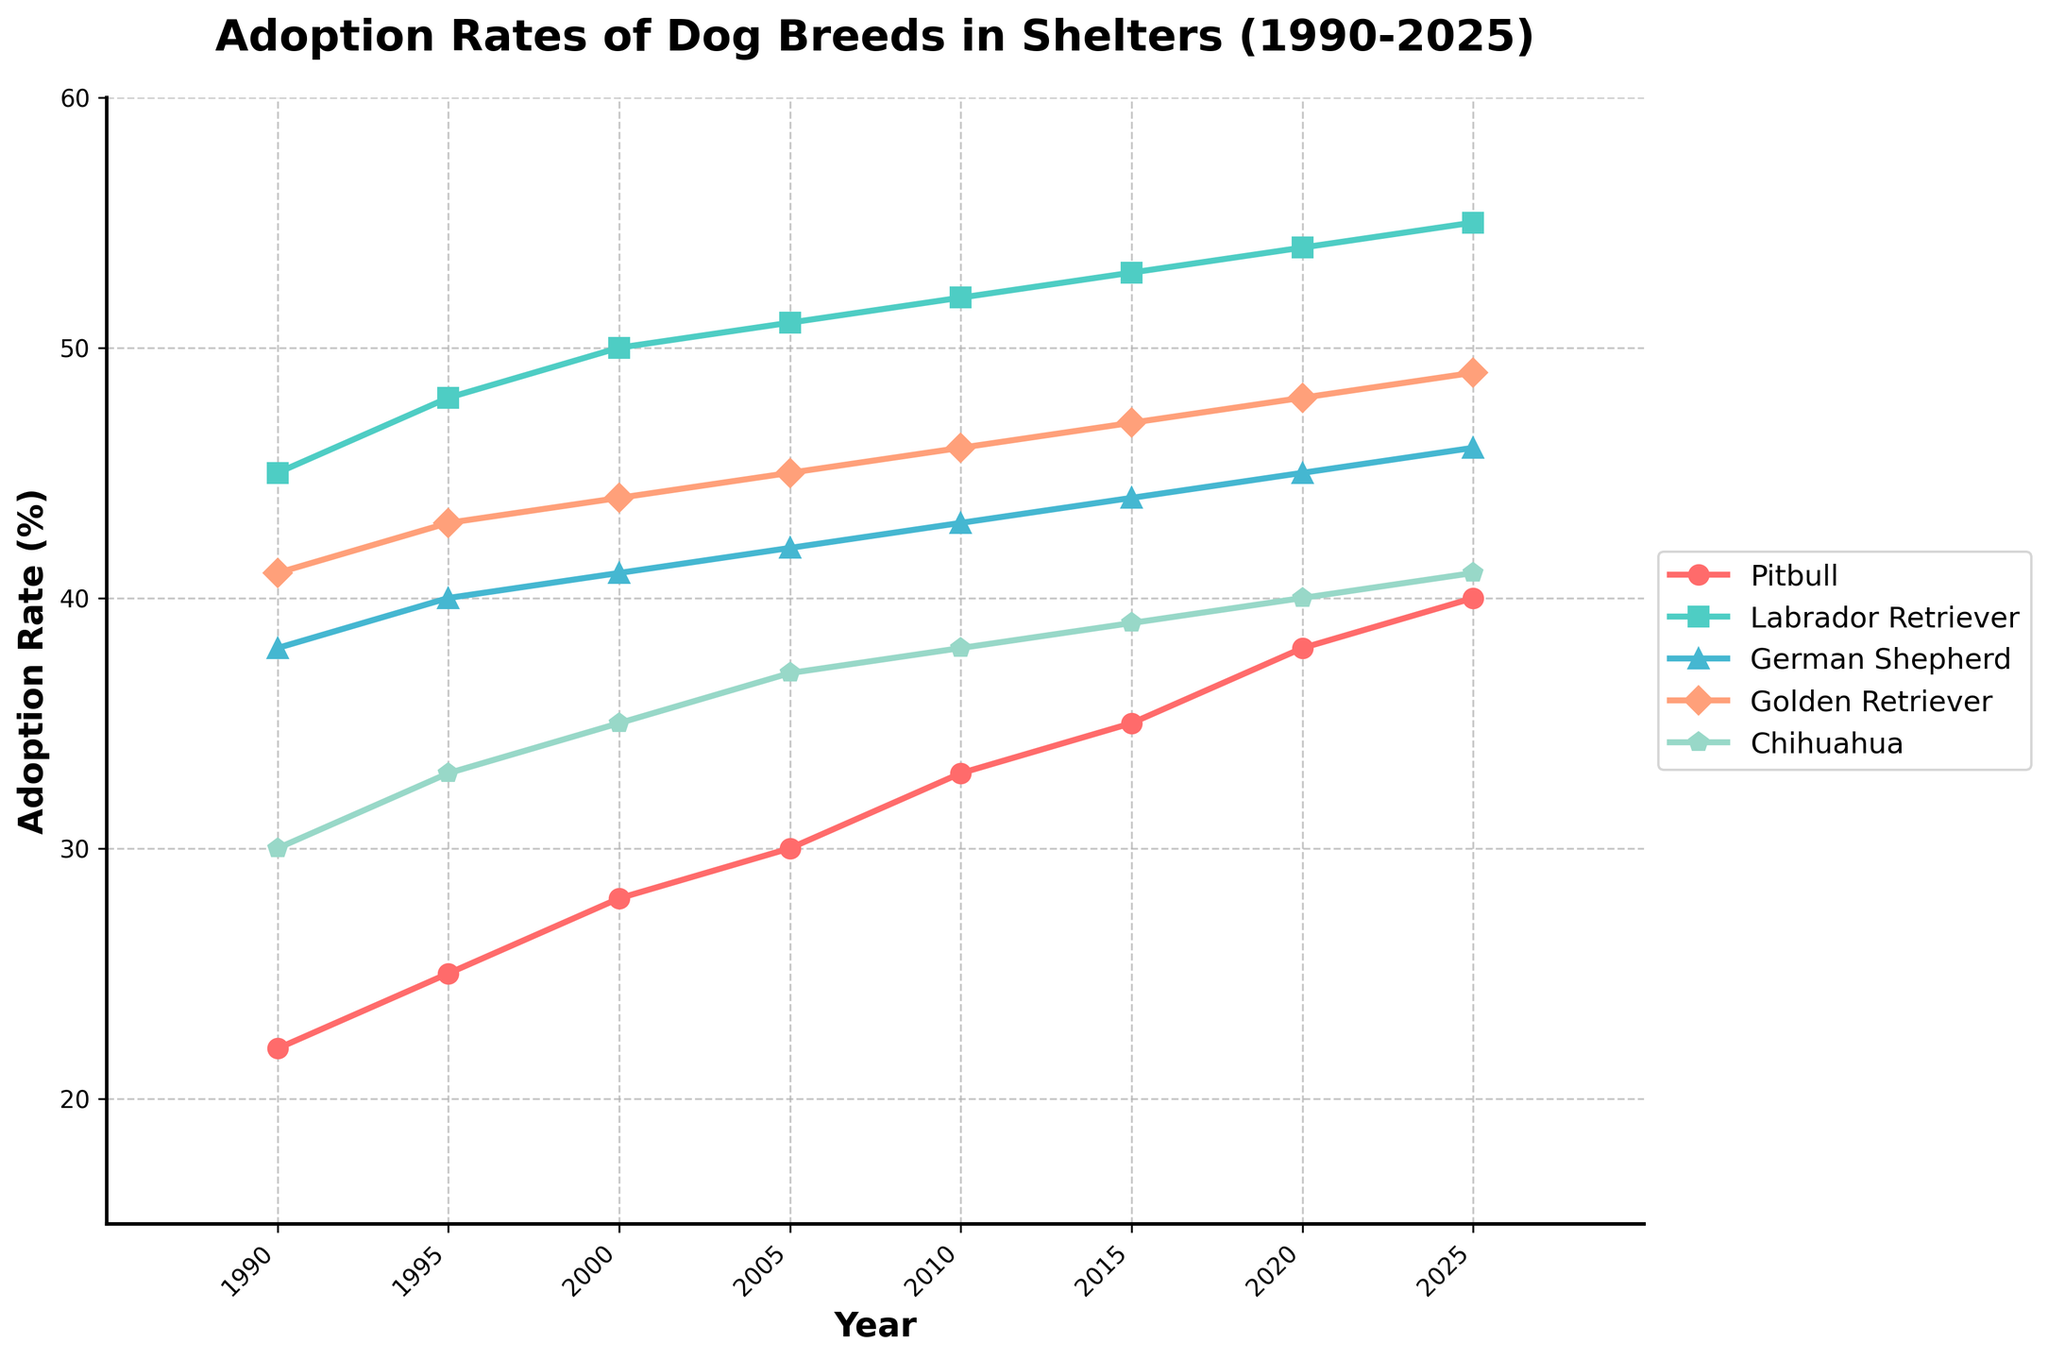What is the trend of pitbull adoption rates from 1990 to 2025? The pitbull adoption rate shows a steady increase from 22% in 1990 to 40% in 2025. Observing the plotted line, it continually rises every five years.
Answer: Steadily increasing How do the adoption rates of pitbulls in 2025 compare to those of German Shepherds in 2000? The pitbull adoption rate in 2025 is 40%, and the German Shepherd adoption rate in 2000 is 41%. Comparing these values reveals that they are almost the same, with only a 1% difference, favoring German Shepherds slightly.
Answer: Almost the same Which dog breed had the highest adoption rate in 2020? The plotted lines show that the Labrador Retriever had the highest adoption rate in 2020 at 54%.
Answer: Labrador Retriever How significant is the difference between the adoption rates of Chihuahua and Golden Retriever in 2010? By referring to the plotted lines, we can see the adoption rate for Chihuahua is 38% and Golden Retriever is 46%. To find the difference: 46% - 38% = 8%.
Answer: 8% Considering the given data, which breed experienced the largest increase in adoption rates from 1990 to 2025? Observing the end values for each breed, we notice the following increases: Pitbull (22% to 40%), Labrador Retriever (45% to 55%), German Shepherd (38% to 46%), Golden Retriever (41% to 49%), and Chihuahua (30% to 41%). Calculating the exact increases: Pitbull (18%), Labrador Retriever (10%), German Shepherd (8%), Golden Retriever (8%), and Chihuahua (11%). Pitbulls showed the largest increase.
Answer: Pitbull How do the adoption rates of Labradors and Pitbulls change from 1995 to 2005? For Labradors: in 1995 the rate is 48%, and in 2005 it is 51%. For Pitbulls: in 1995 the rate is 25%, and in 2005 it is 30%. The change for Labradors is 51% - 48% = 3% and for Pitbulls is 30% - 25% = 5%.
Answer: Labradors increased by 3%, Pitbulls increased by 5% What is the average adoption rate for Golden Retrievers over the span from 1990 to 2025? We sum up the adoption rates for Golden Retrievers across the given years: (41 + 43 + 44 + 45 + 46 + 47 + 48 + 49) = 363. Dividing this by the number of data points (8) gives us the average: 363 / 8 = 45.375%.
Answer: 45.375% In what period do pitbulls have their most significant increase in adoption rate? Looking at the pitbull's plotted line, evaluate the increments between intervals: 1990-1995 (3%), 1995-2000 (3%), 2000-2005 (2%), 2005-2010 (3%), 2010-2015 (2%), 2015-2020 (3%), 2020-2025 (2%). The most significant increase occurred during 1990-1995 and 2010-2015.
Answer: 1990-1995 and 2010-2015 Which breed has the smallest difference in their adoption rate between 1990 and 2025? Evaluating the plotted lines: Pitbull (18%), Labrador Retriever (10%), German Shepherd (8%), Golden Retriever (8%), Chihuahua (11%). Both German Shepherds and Golden Retrievers share the smallest difference of 8%.
Answer: German Shepherds and Golden Retrievers Are there any breeds whose adoption rates never decrease over the entire data span? By inspecting the plot, we note that none of the plotted lines (Pitbull, Labrador Retriever, German Shepherd, Golden Retriever, Chihuahua) show any downward segments from 1990-2025. This means all these breeds have steadily increasing adoption rates.
Answer: All breeds 